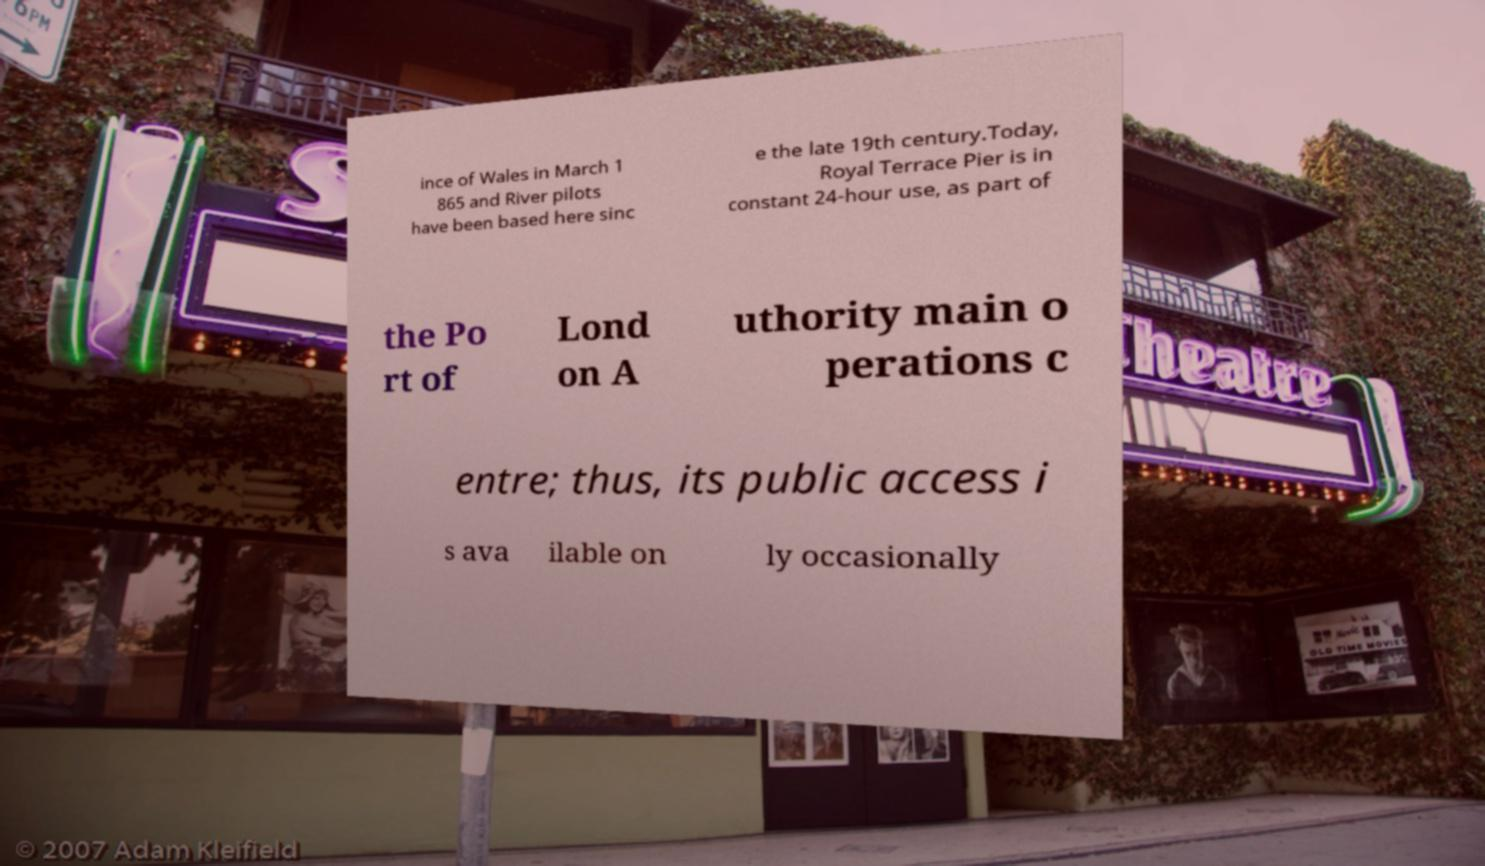There's text embedded in this image that I need extracted. Can you transcribe it verbatim? ince of Wales in March 1 865 and River pilots have been based here sinc e the late 19th century.Today, Royal Terrace Pier is in constant 24-hour use, as part of the Po rt of Lond on A uthority main o perations c entre; thus, its public access i s ava ilable on ly occasionally 